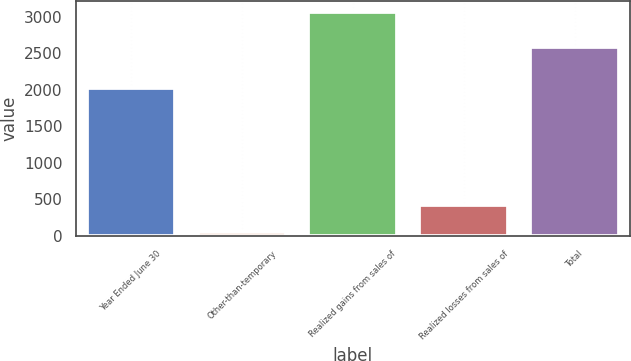Convert chart to OTSL. <chart><loc_0><loc_0><loc_500><loc_500><bar_chart><fcel>Year Ended June 30<fcel>Other-than-temporary<fcel>Realized gains from sales of<fcel>Realized losses from sales of<fcel>Total<nl><fcel>2017<fcel>55<fcel>3064<fcel>426<fcel>2583<nl></chart> 